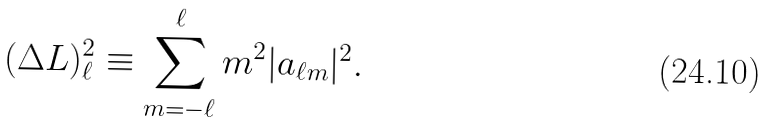Convert formula to latex. <formula><loc_0><loc_0><loc_500><loc_500>( \Delta L ) _ { \ell } ^ { 2 } \equiv \sum _ { m = - \ell } ^ { \ell } m ^ { 2 } | a _ { \ell m } | ^ { 2 } .</formula> 